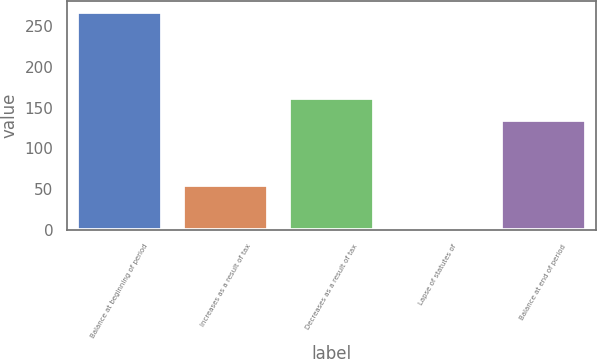<chart> <loc_0><loc_0><loc_500><loc_500><bar_chart><fcel>Balance at beginning of period<fcel>Increases as a result of tax<fcel>Decreases as a result of tax<fcel>Lapse of statutes of<fcel>Balance at end of period<nl><fcel>266.9<fcel>55.3<fcel>161.25<fcel>2.4<fcel>134.8<nl></chart> 